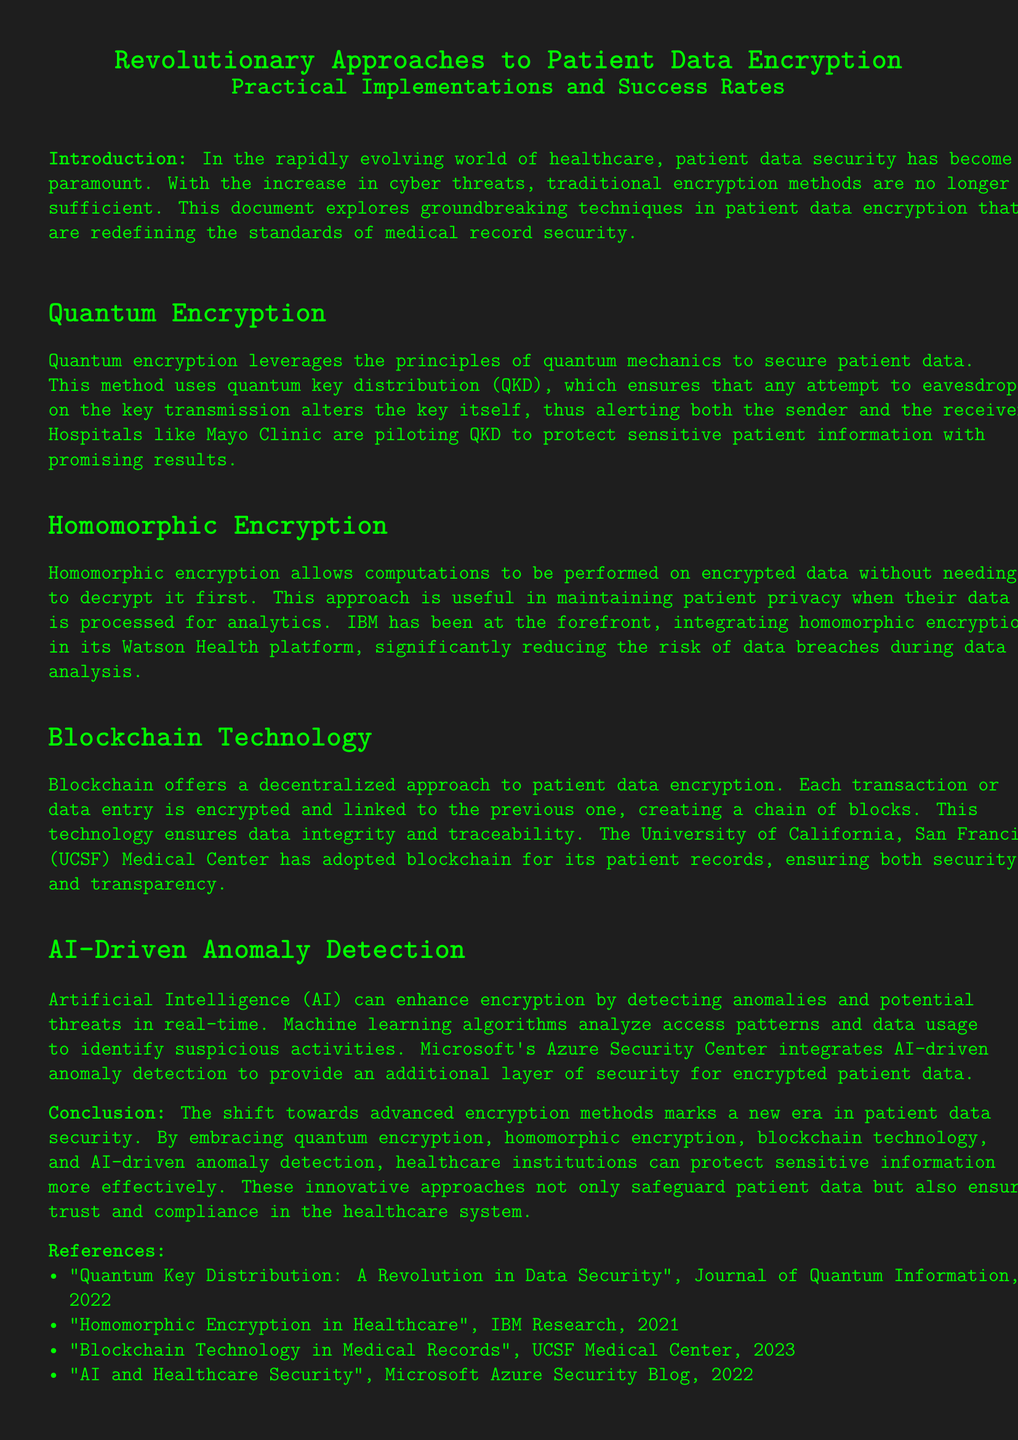What is quantum encryption? Quantum encryption leverages the principles of quantum mechanics to secure patient data.
Answer: Principles of quantum mechanics What does homomorphic encryption allow? Homomorphic encryption allows computations to be performed on encrypted data without needing to decrypt it first.
Answer: Computations on encrypted data Which hospital is piloting quantum key distribution? The document states that hospitals like Mayo Clinic are piloting QKD to protect sensitive patient information.
Answer: Mayo Clinic What technology does UCSF Medical Center use for patient records? The document mentions that UCSF Medical Center has adopted blockchain for its patient records.
Answer: Blockchain Which company integrates AI-driven anomaly detection? Microsoft's Azure Security Center is mentioned as integrating AI-driven anomaly detection for additional security.
Answer: Microsoft What is a primary benefit of quantum key distribution? The method ensures that any attempt to eavesdrop on the key transmission alters the key itself.
Answer: Alerts sender/receiver When was the article on homomorphic encryption published? The document references "Homomorphic Encryption in Healthcare," published in 2021.
Answer: 2021 What is the main focus of this document? The document focuses on revolutionary approaches to patient data encryption and their practical implementations.
Answer: Patient data encryption How does AI enhance encryption? AI detects anomalies and potential threats in real-time, which enhances encryption.
Answer: Detects anomalies 